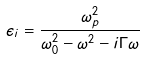Convert formula to latex. <formula><loc_0><loc_0><loc_500><loc_500>\epsilon _ { i } = \frac { \omega _ { p } ^ { 2 } } { \omega _ { 0 } ^ { 2 } - \omega ^ { 2 } - i \Gamma \omega }</formula> 